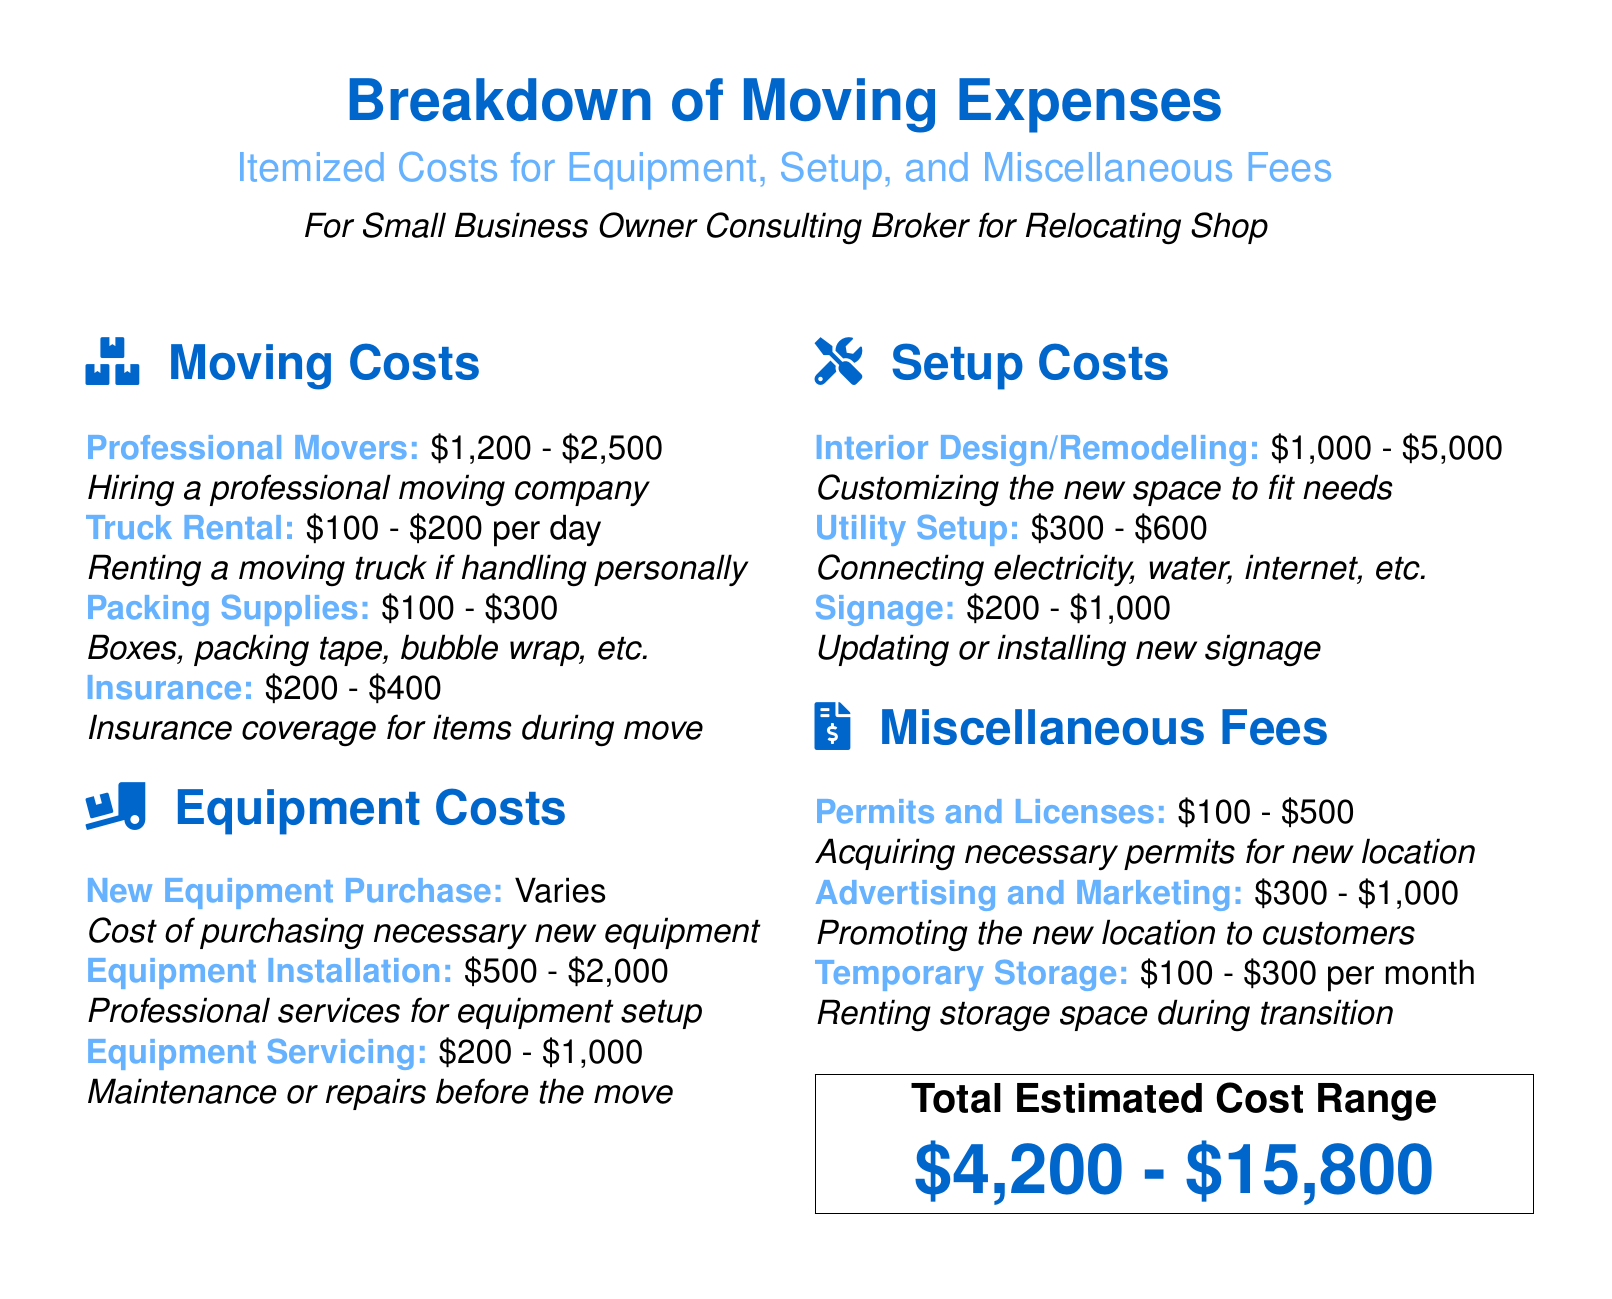What is the cost range for professional movers? The document states that the cost for professional movers ranges from $1,200 to $2,500.
Answer: $1,200 - $2,500 What is included in the packing supplies cost? The document mentions boxes, packing tape, bubble wrap, etc. as part of packing supplies.
Answer: Boxes, packing tape, bubble wrap, etc What is the range for utility setup costs? The document specifies that utility setup costs range from $300 to $600.
Answer: $300 - $600 What is the highest estimate for interior design/remodeling? The document provides a range for interior design/remodeling up to $5,000.
Answer: $5,000 What are the total estimated cost range for moving expenses? The total estimated cost range is aggregated from all expenses listed in the document.
Answer: $4,200 - $15,800 How much could advertising and marketing cost? The document indicates that advertising and marketing could cost between $300 and $1,000.
Answer: $300 - $1,000 What is the cost range for renting a moving truck? The document states that renting a moving truck costs between $100 and $200 per day.
Answer: $100 - $200 per day What is the cost range for permits and licenses? The document provides a cost range for permits and licenses from $100 to $500.
Answer: $100 - $500 What type of document is this? The document is a datasheet that details itemized moving expenses for small business owners.
Answer: Datasheet 